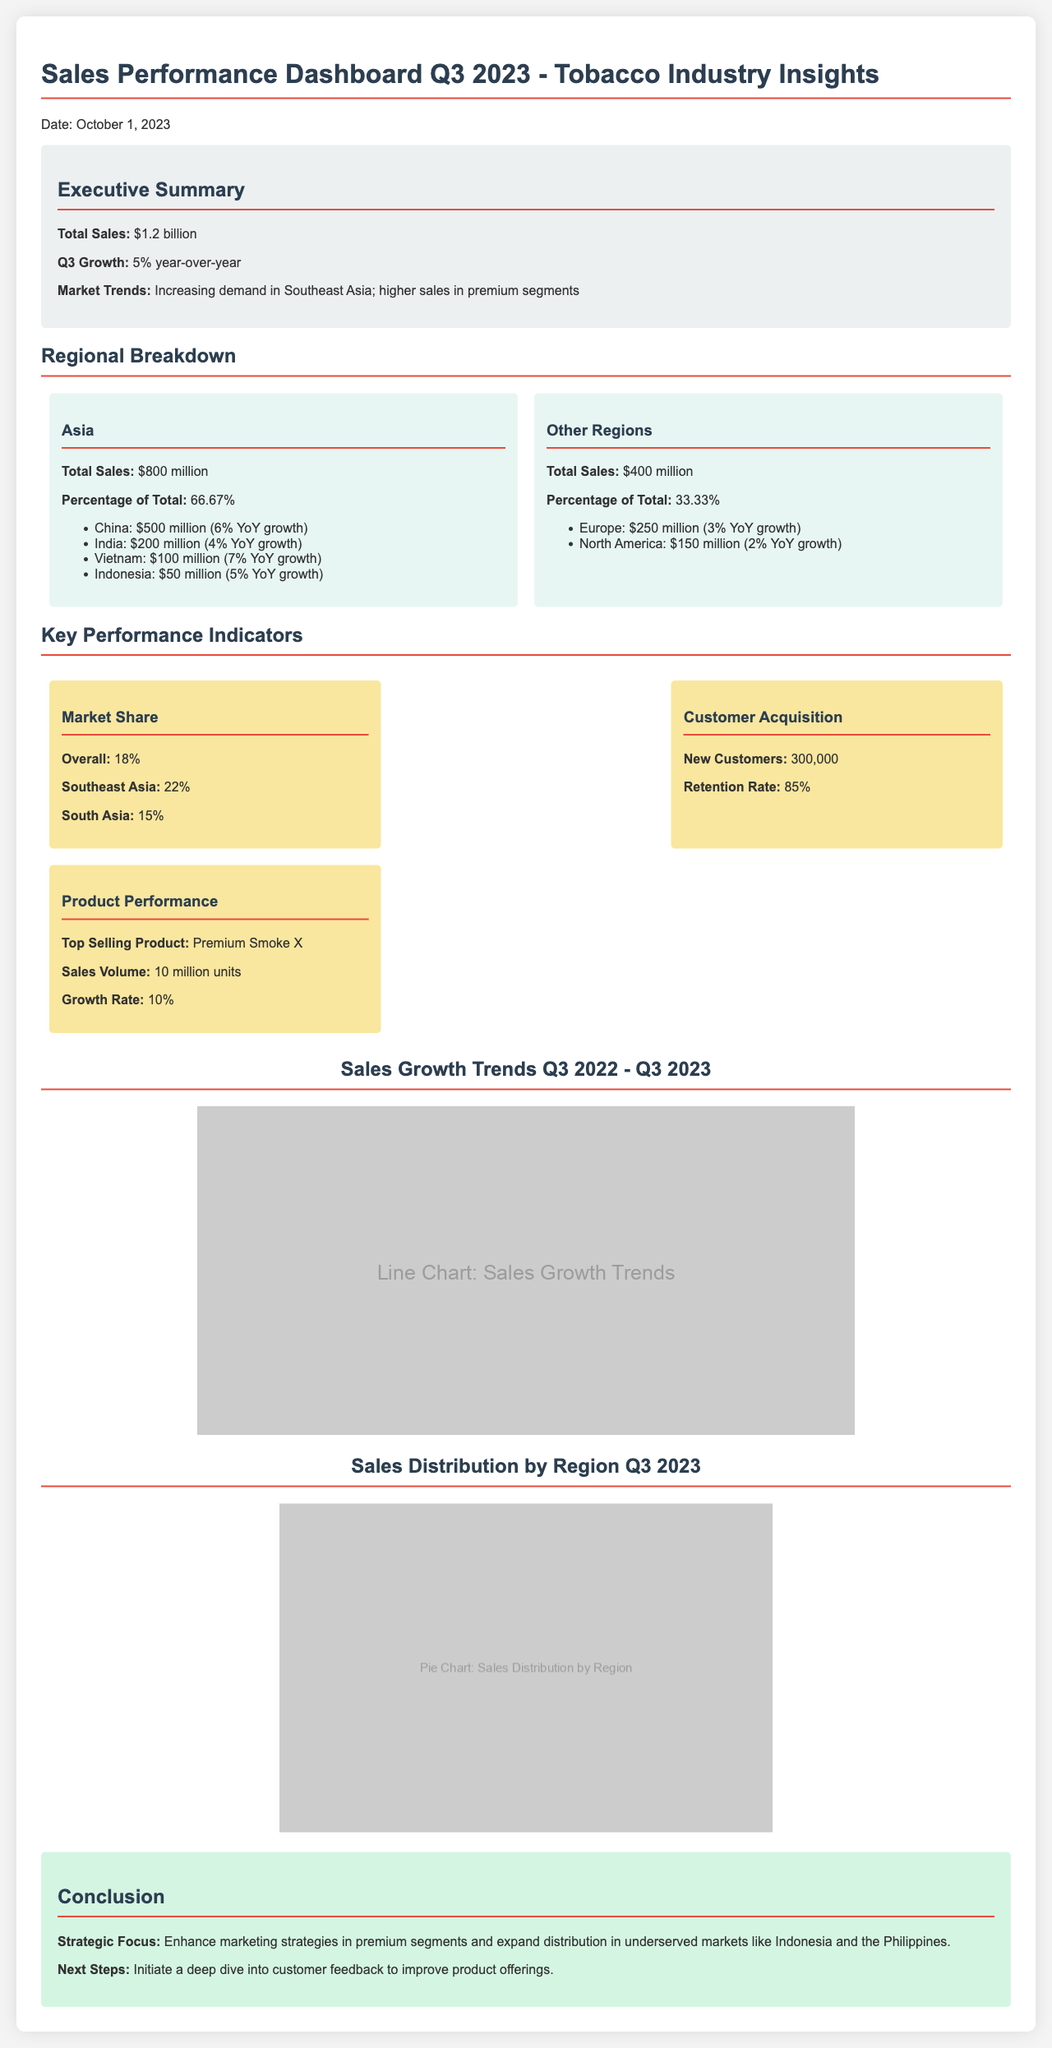What is the total sales for Q3 2023? The total sales for Q3 2023 is clearly mentioned in the executive summary section of the document.
Answer: $1.2 billion What is the year-over-year growth rate for Q3 2023? The growth rate is provided in the executive summary, highlighting the performance in comparison to the previous year.
Answer: 5% What is the total sales for Asia in Q3 2023? The sales figure for Asia is prominently displayed in the regional breakdown section of the document.
Answer: $800 million Which country had the highest sales in Asia? The country with the highest sales in Asia is listed under the regional breakdown section with their respective sales performance.
Answer: China How many new customers were acquired in Q3 2023? The number of new customers is stated within the Key Performance Indicators section of the document.
Answer: 300,000 What is the market share percentage for Southeast Asia? The document provides specific figures for market share across different regions in the KPI section.
Answer: 22% Which product had the highest sales volume? The top-selling product is highlighted in the product performance subsection of the KPIs.
Answer: Premium Smoke X What strategic focus is suggested in the conclusion? The conclusion emphasizes a specific focus that aligns with the findings and projections in the document.
Answer: Enhance marketing strategies in premium segments What percentage of total sales does Other Regions occupy? The figure for Other Regions' percentage of total sales can be found in the regional breakdown section.
Answer: 33.33% 